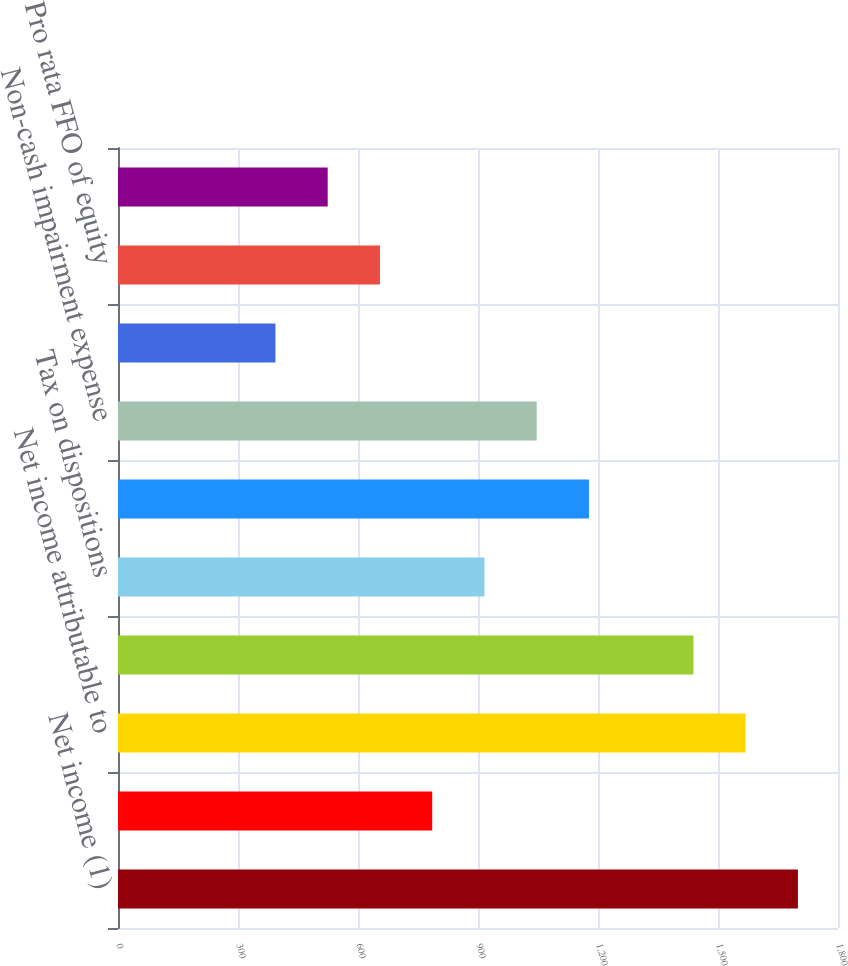Convert chart. <chart><loc_0><loc_0><loc_500><loc_500><bar_chart><fcel>Net income (1)<fcel>Less Net income attributable<fcel>Net income attributable to<fcel>Gain on dispositions (2)<fcel>Tax on dispositions<fcel>Depreciation and amortization<fcel>Non-cash impairment expense<fcel>Equity in earnings of<fcel>Pro rata FFO of equity<fcel>FFO adjustment for<nl><fcel>1699.83<fcel>785.49<fcel>1569.21<fcel>1438.59<fcel>916.11<fcel>1177.35<fcel>1046.73<fcel>393.63<fcel>654.87<fcel>524.25<nl></chart> 